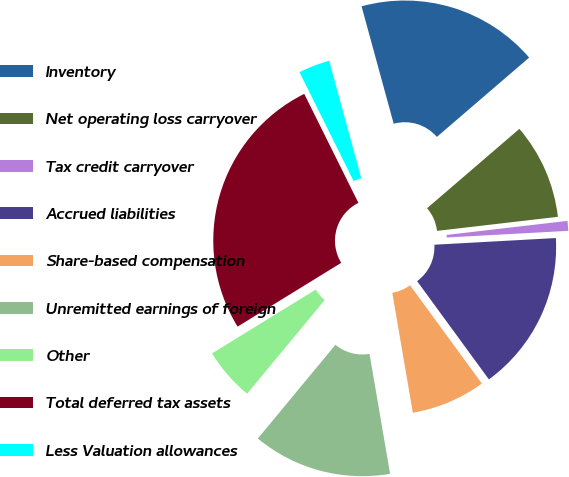<chart> <loc_0><loc_0><loc_500><loc_500><pie_chart><fcel>Inventory<fcel>Net operating loss carryover<fcel>Tax credit carryover<fcel>Accrued liabilities<fcel>Share-based compensation<fcel>Unremitted earnings of foreign<fcel>Other<fcel>Total deferred tax assets<fcel>Less Valuation allowances<nl><fcel>17.95%<fcel>9.46%<fcel>0.97%<fcel>15.83%<fcel>7.34%<fcel>13.71%<fcel>5.21%<fcel>26.44%<fcel>3.09%<nl></chart> 